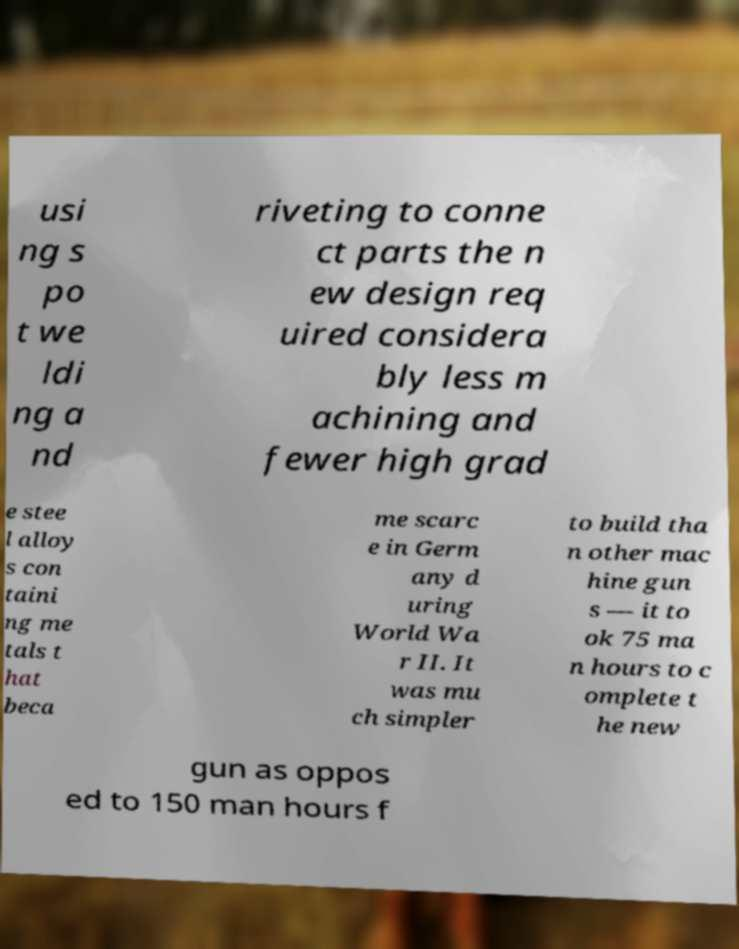What messages or text are displayed in this image? I need them in a readable, typed format. usi ng s po t we ldi ng a nd riveting to conne ct parts the n ew design req uired considera bly less m achining and fewer high grad e stee l alloy s con taini ng me tals t hat beca me scarc e in Germ any d uring World Wa r II. It was mu ch simpler to build tha n other mac hine gun s — it to ok 75 ma n hours to c omplete t he new gun as oppos ed to 150 man hours f 